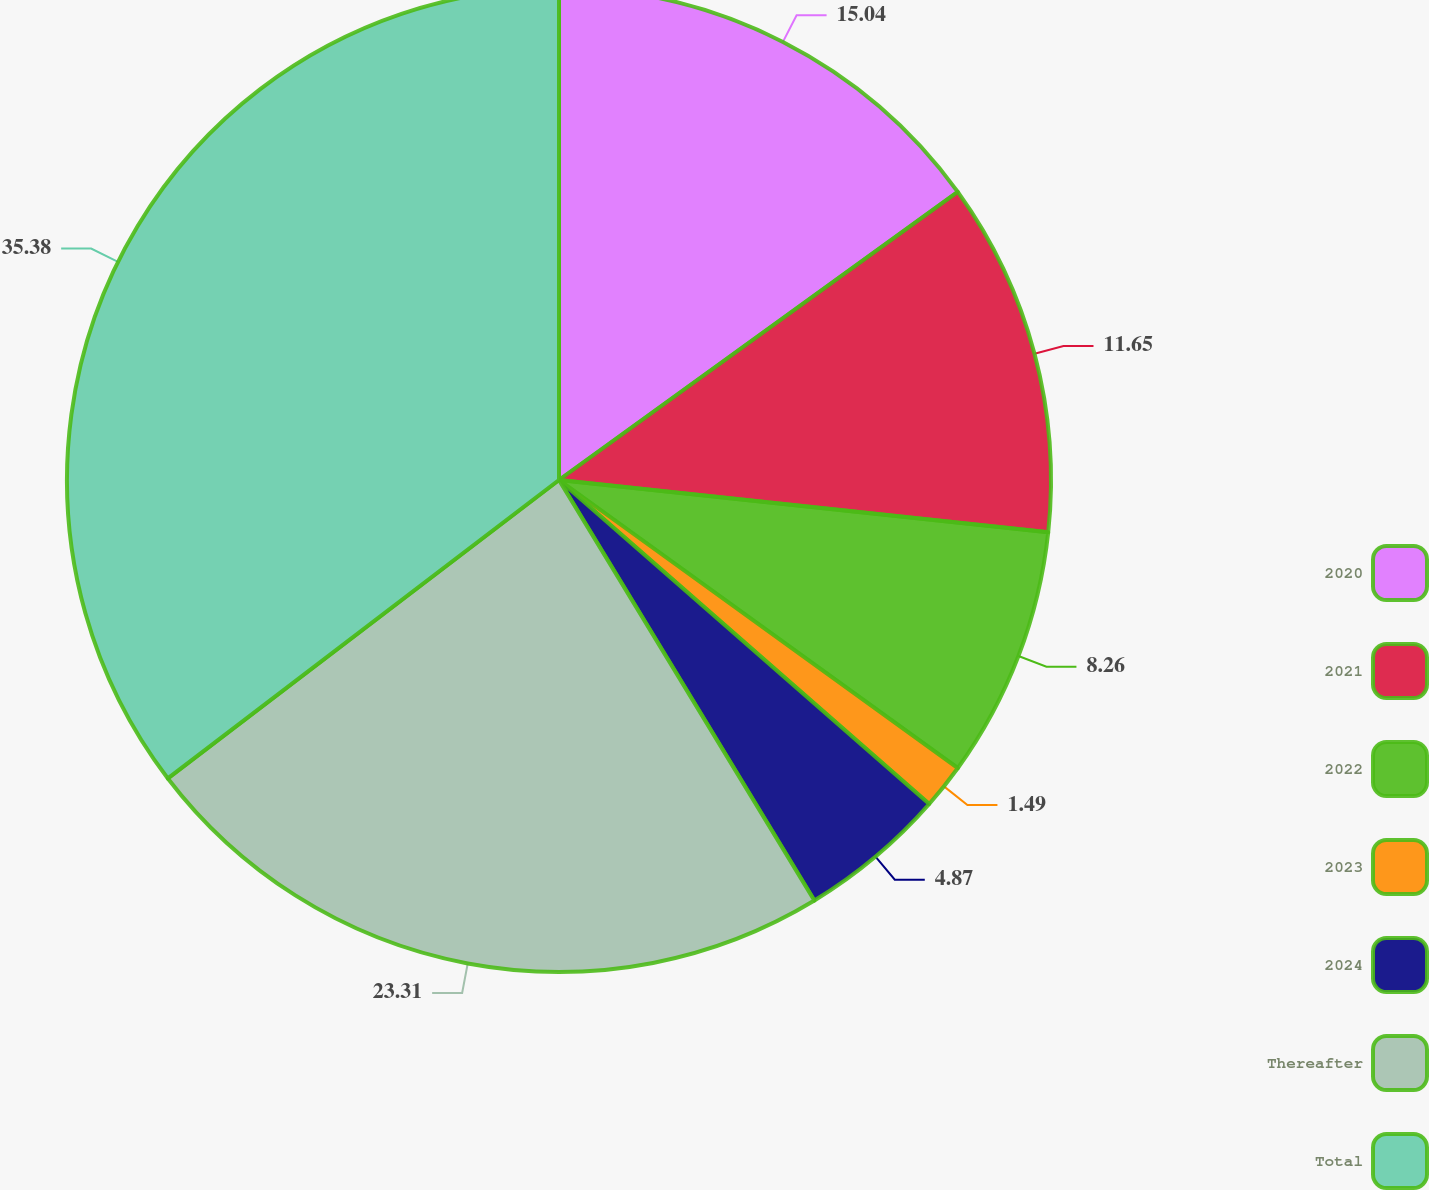Convert chart. <chart><loc_0><loc_0><loc_500><loc_500><pie_chart><fcel>2020<fcel>2021<fcel>2022<fcel>2023<fcel>2024<fcel>Thereafter<fcel>Total<nl><fcel>15.04%<fcel>11.65%<fcel>8.26%<fcel>1.49%<fcel>4.87%<fcel>23.31%<fcel>35.37%<nl></chart> 